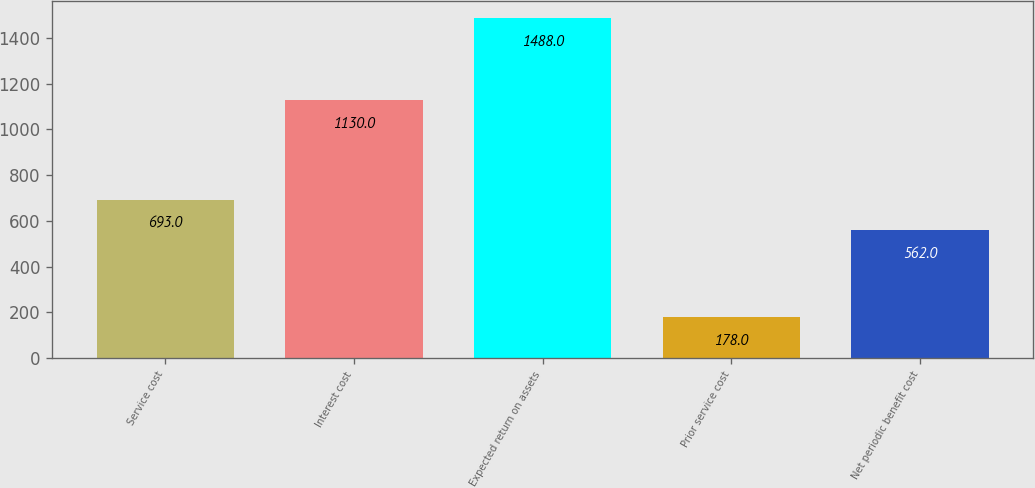<chart> <loc_0><loc_0><loc_500><loc_500><bar_chart><fcel>Service cost<fcel>Interest cost<fcel>Expected return on assets<fcel>Prior service cost<fcel>Net periodic benefit cost<nl><fcel>693<fcel>1130<fcel>1488<fcel>178<fcel>562<nl></chart> 